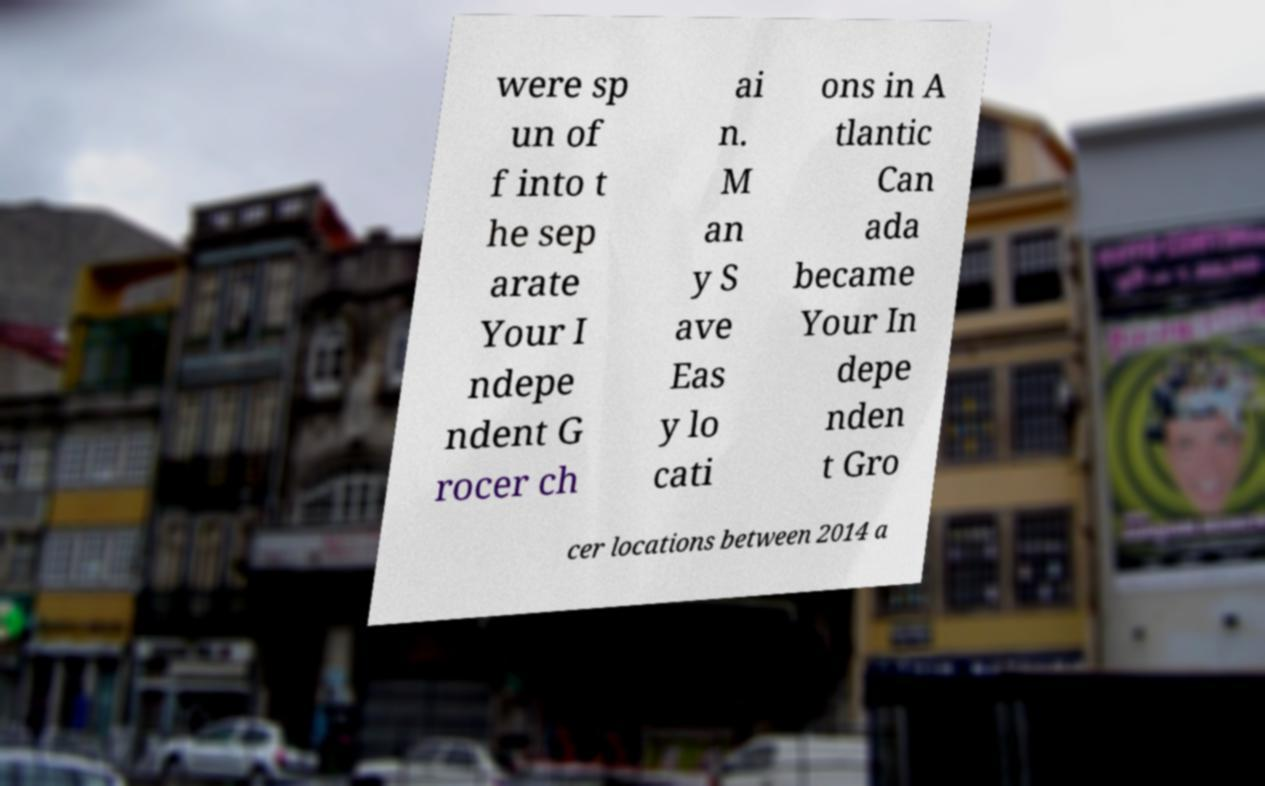Can you read and provide the text displayed in the image?This photo seems to have some interesting text. Can you extract and type it out for me? were sp un of f into t he sep arate Your I ndepe ndent G rocer ch ai n. M an y S ave Eas y lo cati ons in A tlantic Can ada became Your In depe nden t Gro cer locations between 2014 a 